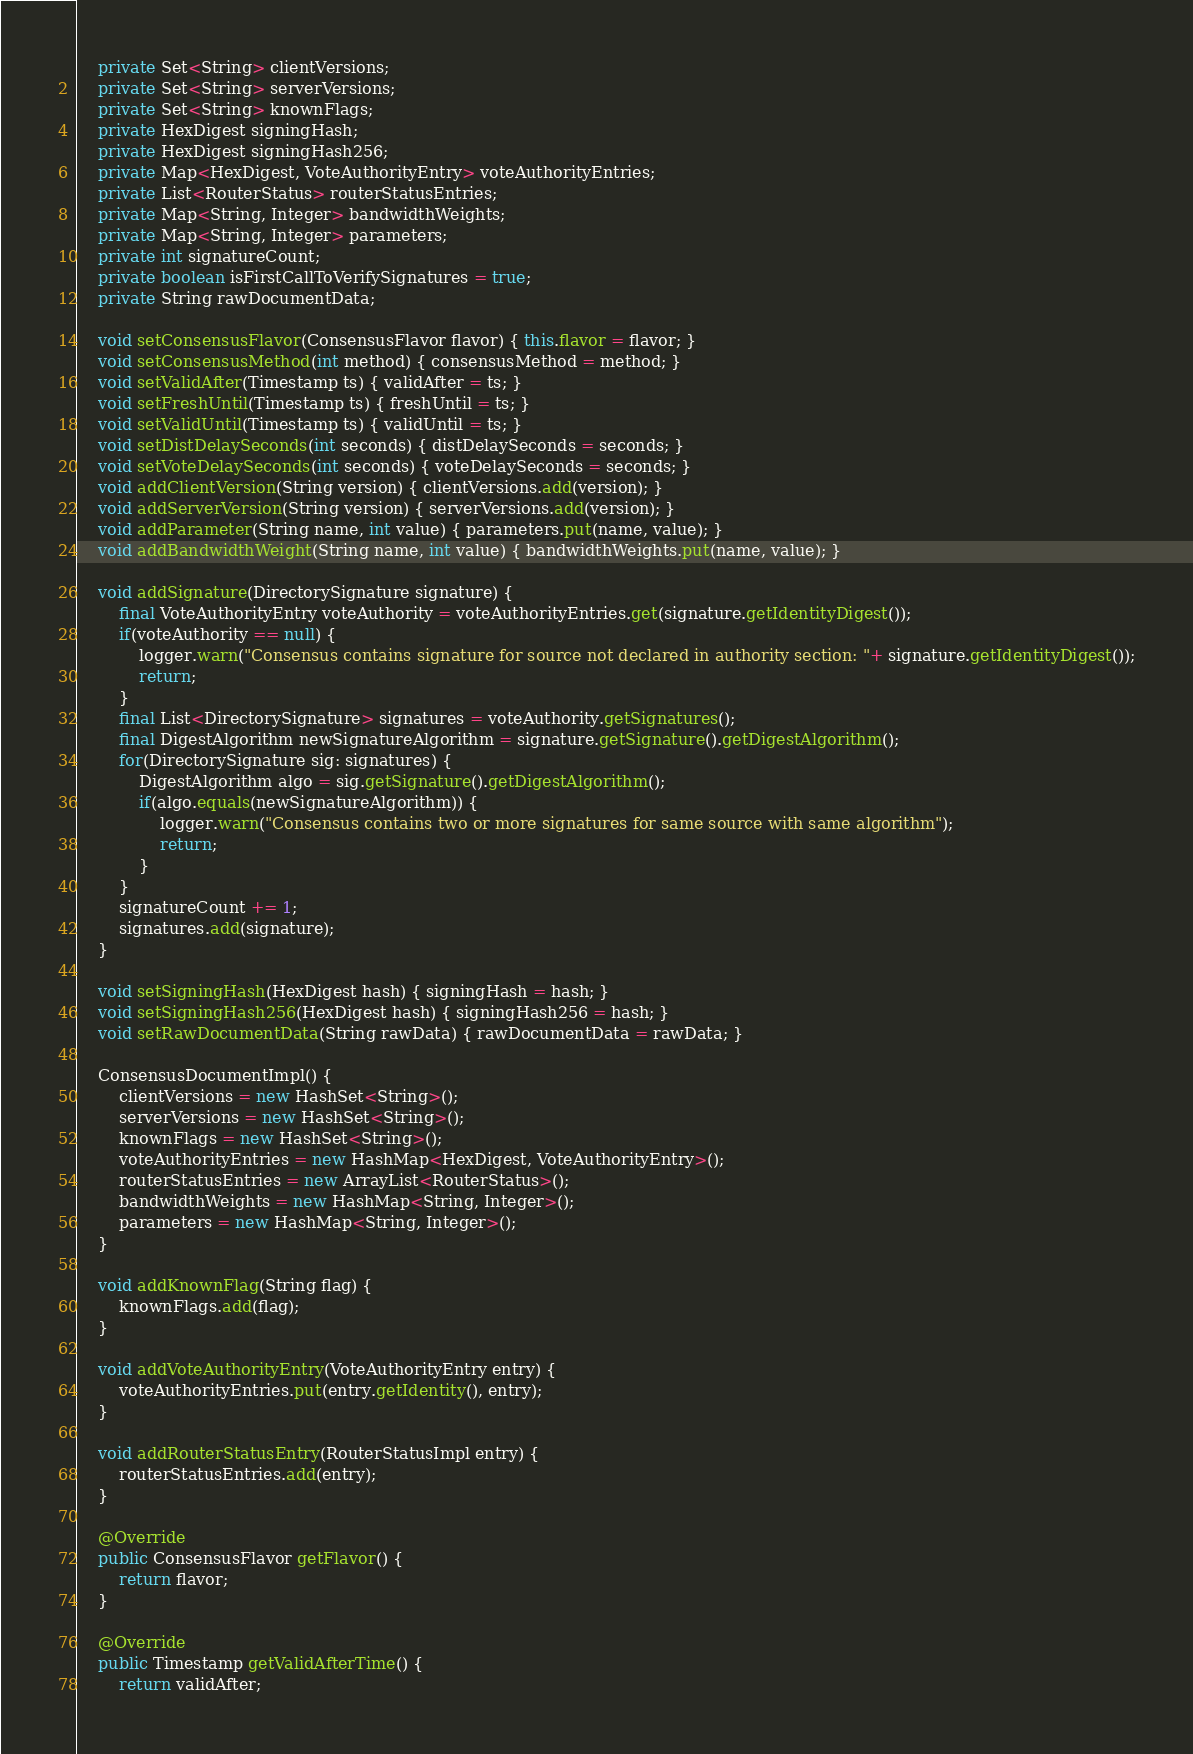Convert code to text. <code><loc_0><loc_0><loc_500><loc_500><_Java_>    private Set<String> clientVersions;
    private Set<String> serverVersions;
    private Set<String> knownFlags;
    private HexDigest signingHash;
    private HexDigest signingHash256;
    private Map<HexDigest, VoteAuthorityEntry> voteAuthorityEntries;
    private List<RouterStatus> routerStatusEntries;
    private Map<String, Integer> bandwidthWeights;
    private Map<String, Integer> parameters;
    private int signatureCount;
    private boolean isFirstCallToVerifySignatures = true;
    private String rawDocumentData;

    void setConsensusFlavor(ConsensusFlavor flavor) { this.flavor = flavor; }
    void setConsensusMethod(int method) { consensusMethod = method; }
    void setValidAfter(Timestamp ts) { validAfter = ts; }
    void setFreshUntil(Timestamp ts) { freshUntil = ts; }
    void setValidUntil(Timestamp ts) { validUntil = ts; }
    void setDistDelaySeconds(int seconds) { distDelaySeconds = seconds; }
    void setVoteDelaySeconds(int seconds) { voteDelaySeconds = seconds; }
    void addClientVersion(String version) { clientVersions.add(version); }
    void addServerVersion(String version) { serverVersions.add(version); }
    void addParameter(String name, int value) { parameters.put(name, value); }
    void addBandwidthWeight(String name, int value) { bandwidthWeights.put(name, value); }

    void addSignature(DirectorySignature signature) {
        final VoteAuthorityEntry voteAuthority = voteAuthorityEntries.get(signature.getIdentityDigest());
        if(voteAuthority == null) {
            logger.warn("Consensus contains signature for source not declared in authority section: "+ signature.getIdentityDigest());
            return;
        }
        final List<DirectorySignature> signatures = voteAuthority.getSignatures();
        final DigestAlgorithm newSignatureAlgorithm = signature.getSignature().getDigestAlgorithm();
        for(DirectorySignature sig: signatures) {
            DigestAlgorithm algo = sig.getSignature().getDigestAlgorithm();
            if(algo.equals(newSignatureAlgorithm)) {
                logger.warn("Consensus contains two or more signatures for same source with same algorithm");
                return;
            }
        }
        signatureCount += 1;
        signatures.add(signature);
    }

    void setSigningHash(HexDigest hash) { signingHash = hash; }
    void setSigningHash256(HexDigest hash) { signingHash256 = hash; }
    void setRawDocumentData(String rawData) { rawDocumentData = rawData; }

    ConsensusDocumentImpl() {
        clientVersions = new HashSet<String>();
        serverVersions = new HashSet<String>();
        knownFlags = new HashSet<String>();
        voteAuthorityEntries = new HashMap<HexDigest, VoteAuthorityEntry>();
        routerStatusEntries = new ArrayList<RouterStatus>();
        bandwidthWeights = new HashMap<String, Integer>();
        parameters = new HashMap<String, Integer>();
    }

    void addKnownFlag(String flag) {
        knownFlags.add(flag);
    }

    void addVoteAuthorityEntry(VoteAuthorityEntry entry) {
        voteAuthorityEntries.put(entry.getIdentity(), entry);
    }

    void addRouterStatusEntry(RouterStatusImpl entry) {
        routerStatusEntries.add(entry);
    }

    @Override
    public ConsensusFlavor getFlavor() {
        return flavor;
    }

    @Override
    public Timestamp getValidAfterTime() {
        return validAfter;</code> 